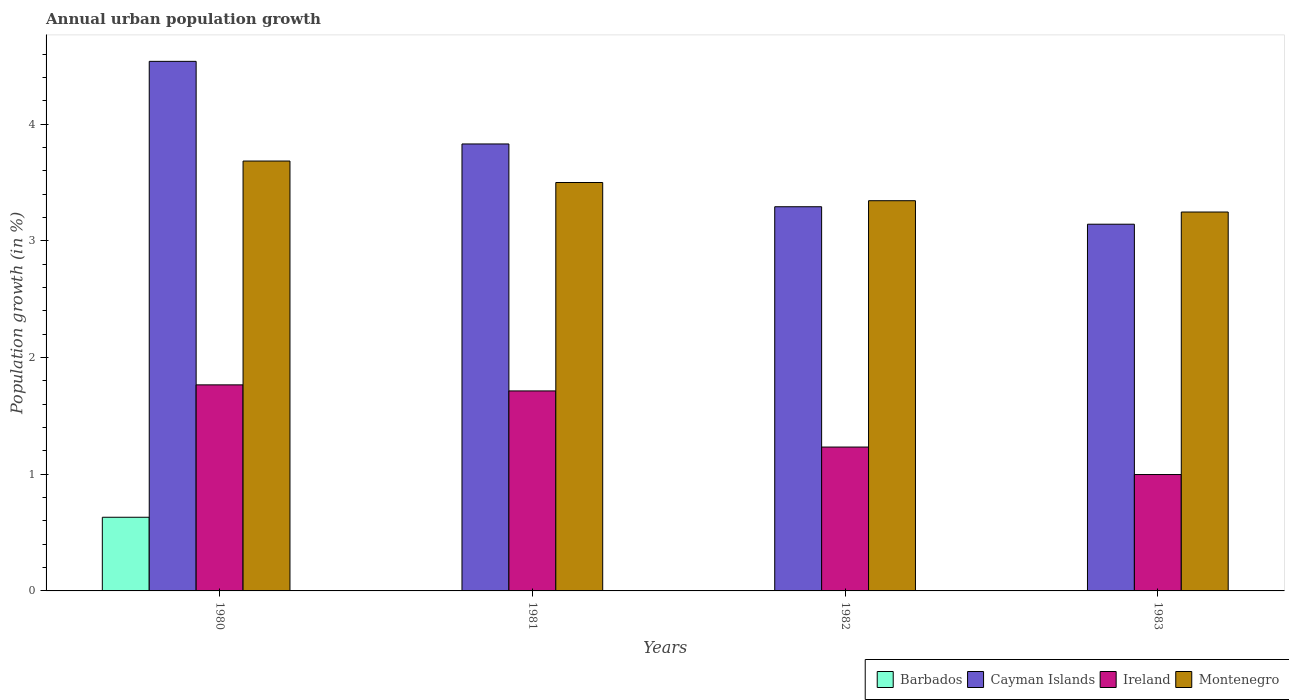How many different coloured bars are there?
Offer a very short reply. 4. Are the number of bars per tick equal to the number of legend labels?
Keep it short and to the point. No. Are the number of bars on each tick of the X-axis equal?
Give a very brief answer. No. How many bars are there on the 2nd tick from the right?
Offer a very short reply. 3. What is the label of the 4th group of bars from the left?
Your response must be concise. 1983. What is the percentage of urban population growth in Barbados in 1982?
Offer a very short reply. 0. Across all years, what is the maximum percentage of urban population growth in Cayman Islands?
Ensure brevity in your answer.  4.54. Across all years, what is the minimum percentage of urban population growth in Barbados?
Offer a terse response. 0. In which year was the percentage of urban population growth in Ireland maximum?
Offer a very short reply. 1980. What is the total percentage of urban population growth in Ireland in the graph?
Your answer should be compact. 5.71. What is the difference between the percentage of urban population growth in Ireland in 1982 and that in 1983?
Keep it short and to the point. 0.24. What is the difference between the percentage of urban population growth in Ireland in 1981 and the percentage of urban population growth in Cayman Islands in 1983?
Keep it short and to the point. -1.43. What is the average percentage of urban population growth in Ireland per year?
Make the answer very short. 1.43. In the year 1982, what is the difference between the percentage of urban population growth in Montenegro and percentage of urban population growth in Ireland?
Your answer should be compact. 2.11. What is the ratio of the percentage of urban population growth in Ireland in 1981 to that in 1982?
Give a very brief answer. 1.39. Is the percentage of urban population growth in Cayman Islands in 1981 less than that in 1983?
Your answer should be compact. No. Is the difference between the percentage of urban population growth in Montenegro in 1980 and 1982 greater than the difference between the percentage of urban population growth in Ireland in 1980 and 1982?
Provide a succinct answer. No. What is the difference between the highest and the second highest percentage of urban population growth in Montenegro?
Make the answer very short. 0.18. What is the difference between the highest and the lowest percentage of urban population growth in Ireland?
Keep it short and to the point. 0.77. In how many years, is the percentage of urban population growth in Ireland greater than the average percentage of urban population growth in Ireland taken over all years?
Offer a terse response. 2. Is the sum of the percentage of urban population growth in Cayman Islands in 1981 and 1983 greater than the maximum percentage of urban population growth in Montenegro across all years?
Give a very brief answer. Yes. Is it the case that in every year, the sum of the percentage of urban population growth in Montenegro and percentage of urban population growth in Cayman Islands is greater than the sum of percentage of urban population growth in Barbados and percentage of urban population growth in Ireland?
Provide a short and direct response. Yes. Are all the bars in the graph horizontal?
Your answer should be very brief. No. What is the difference between two consecutive major ticks on the Y-axis?
Your answer should be very brief. 1. Where does the legend appear in the graph?
Make the answer very short. Bottom right. How are the legend labels stacked?
Your answer should be compact. Horizontal. What is the title of the graph?
Provide a succinct answer. Annual urban population growth. Does "Guinea" appear as one of the legend labels in the graph?
Keep it short and to the point. No. What is the label or title of the Y-axis?
Provide a short and direct response. Population growth (in %). What is the Population growth (in %) of Barbados in 1980?
Offer a terse response. 0.63. What is the Population growth (in %) of Cayman Islands in 1980?
Make the answer very short. 4.54. What is the Population growth (in %) of Ireland in 1980?
Provide a succinct answer. 1.77. What is the Population growth (in %) in Montenegro in 1980?
Your answer should be compact. 3.68. What is the Population growth (in %) in Cayman Islands in 1981?
Ensure brevity in your answer.  3.83. What is the Population growth (in %) in Ireland in 1981?
Provide a succinct answer. 1.71. What is the Population growth (in %) of Montenegro in 1981?
Provide a short and direct response. 3.5. What is the Population growth (in %) of Barbados in 1982?
Your response must be concise. 0. What is the Population growth (in %) of Cayman Islands in 1982?
Your answer should be very brief. 3.29. What is the Population growth (in %) of Ireland in 1982?
Give a very brief answer. 1.23. What is the Population growth (in %) in Montenegro in 1982?
Your answer should be compact. 3.34. What is the Population growth (in %) of Barbados in 1983?
Make the answer very short. 0. What is the Population growth (in %) of Cayman Islands in 1983?
Offer a very short reply. 3.14. What is the Population growth (in %) of Ireland in 1983?
Make the answer very short. 1. What is the Population growth (in %) in Montenegro in 1983?
Offer a terse response. 3.25. Across all years, what is the maximum Population growth (in %) in Barbados?
Make the answer very short. 0.63. Across all years, what is the maximum Population growth (in %) of Cayman Islands?
Make the answer very short. 4.54. Across all years, what is the maximum Population growth (in %) in Ireland?
Offer a very short reply. 1.77. Across all years, what is the maximum Population growth (in %) in Montenegro?
Your response must be concise. 3.68. Across all years, what is the minimum Population growth (in %) of Barbados?
Make the answer very short. 0. Across all years, what is the minimum Population growth (in %) of Cayman Islands?
Make the answer very short. 3.14. Across all years, what is the minimum Population growth (in %) of Ireland?
Your answer should be compact. 1. Across all years, what is the minimum Population growth (in %) in Montenegro?
Provide a succinct answer. 3.25. What is the total Population growth (in %) of Barbados in the graph?
Your answer should be very brief. 0.63. What is the total Population growth (in %) of Cayman Islands in the graph?
Offer a very short reply. 14.8. What is the total Population growth (in %) in Ireland in the graph?
Provide a succinct answer. 5.71. What is the total Population growth (in %) in Montenegro in the graph?
Provide a short and direct response. 13.77. What is the difference between the Population growth (in %) of Cayman Islands in 1980 and that in 1981?
Provide a succinct answer. 0.71. What is the difference between the Population growth (in %) of Ireland in 1980 and that in 1981?
Provide a short and direct response. 0.05. What is the difference between the Population growth (in %) of Montenegro in 1980 and that in 1981?
Provide a short and direct response. 0.18. What is the difference between the Population growth (in %) of Cayman Islands in 1980 and that in 1982?
Your response must be concise. 1.25. What is the difference between the Population growth (in %) of Ireland in 1980 and that in 1982?
Your answer should be compact. 0.53. What is the difference between the Population growth (in %) in Montenegro in 1980 and that in 1982?
Provide a short and direct response. 0.34. What is the difference between the Population growth (in %) of Cayman Islands in 1980 and that in 1983?
Make the answer very short. 1.4. What is the difference between the Population growth (in %) in Ireland in 1980 and that in 1983?
Offer a terse response. 0.77. What is the difference between the Population growth (in %) in Montenegro in 1980 and that in 1983?
Your answer should be very brief. 0.44. What is the difference between the Population growth (in %) in Cayman Islands in 1981 and that in 1982?
Provide a succinct answer. 0.54. What is the difference between the Population growth (in %) of Ireland in 1981 and that in 1982?
Make the answer very short. 0.48. What is the difference between the Population growth (in %) of Montenegro in 1981 and that in 1982?
Ensure brevity in your answer.  0.16. What is the difference between the Population growth (in %) of Cayman Islands in 1981 and that in 1983?
Keep it short and to the point. 0.69. What is the difference between the Population growth (in %) in Ireland in 1981 and that in 1983?
Make the answer very short. 0.72. What is the difference between the Population growth (in %) of Montenegro in 1981 and that in 1983?
Provide a short and direct response. 0.25. What is the difference between the Population growth (in %) of Cayman Islands in 1982 and that in 1983?
Offer a very short reply. 0.15. What is the difference between the Population growth (in %) of Ireland in 1982 and that in 1983?
Provide a short and direct response. 0.24. What is the difference between the Population growth (in %) in Montenegro in 1982 and that in 1983?
Your response must be concise. 0.1. What is the difference between the Population growth (in %) of Barbados in 1980 and the Population growth (in %) of Cayman Islands in 1981?
Your answer should be very brief. -3.2. What is the difference between the Population growth (in %) of Barbados in 1980 and the Population growth (in %) of Ireland in 1981?
Give a very brief answer. -1.08. What is the difference between the Population growth (in %) of Barbados in 1980 and the Population growth (in %) of Montenegro in 1981?
Your answer should be very brief. -2.87. What is the difference between the Population growth (in %) of Cayman Islands in 1980 and the Population growth (in %) of Ireland in 1981?
Your response must be concise. 2.82. What is the difference between the Population growth (in %) of Cayman Islands in 1980 and the Population growth (in %) of Montenegro in 1981?
Provide a succinct answer. 1.04. What is the difference between the Population growth (in %) in Ireland in 1980 and the Population growth (in %) in Montenegro in 1981?
Your answer should be very brief. -1.73. What is the difference between the Population growth (in %) in Barbados in 1980 and the Population growth (in %) in Cayman Islands in 1982?
Make the answer very short. -2.66. What is the difference between the Population growth (in %) of Barbados in 1980 and the Population growth (in %) of Ireland in 1982?
Offer a very short reply. -0.6. What is the difference between the Population growth (in %) of Barbados in 1980 and the Population growth (in %) of Montenegro in 1982?
Your answer should be very brief. -2.71. What is the difference between the Population growth (in %) of Cayman Islands in 1980 and the Population growth (in %) of Ireland in 1982?
Provide a succinct answer. 3.3. What is the difference between the Population growth (in %) in Cayman Islands in 1980 and the Population growth (in %) in Montenegro in 1982?
Offer a terse response. 1.19. What is the difference between the Population growth (in %) of Ireland in 1980 and the Population growth (in %) of Montenegro in 1982?
Your response must be concise. -1.58. What is the difference between the Population growth (in %) in Barbados in 1980 and the Population growth (in %) in Cayman Islands in 1983?
Offer a terse response. -2.51. What is the difference between the Population growth (in %) of Barbados in 1980 and the Population growth (in %) of Ireland in 1983?
Offer a terse response. -0.37. What is the difference between the Population growth (in %) of Barbados in 1980 and the Population growth (in %) of Montenegro in 1983?
Provide a succinct answer. -2.62. What is the difference between the Population growth (in %) of Cayman Islands in 1980 and the Population growth (in %) of Ireland in 1983?
Keep it short and to the point. 3.54. What is the difference between the Population growth (in %) in Cayman Islands in 1980 and the Population growth (in %) in Montenegro in 1983?
Your answer should be compact. 1.29. What is the difference between the Population growth (in %) in Ireland in 1980 and the Population growth (in %) in Montenegro in 1983?
Your answer should be very brief. -1.48. What is the difference between the Population growth (in %) of Cayman Islands in 1981 and the Population growth (in %) of Ireland in 1982?
Your response must be concise. 2.6. What is the difference between the Population growth (in %) of Cayman Islands in 1981 and the Population growth (in %) of Montenegro in 1982?
Give a very brief answer. 0.49. What is the difference between the Population growth (in %) of Ireland in 1981 and the Population growth (in %) of Montenegro in 1982?
Offer a very short reply. -1.63. What is the difference between the Population growth (in %) of Cayman Islands in 1981 and the Population growth (in %) of Ireland in 1983?
Provide a short and direct response. 2.83. What is the difference between the Population growth (in %) in Cayman Islands in 1981 and the Population growth (in %) in Montenegro in 1983?
Your answer should be very brief. 0.58. What is the difference between the Population growth (in %) of Ireland in 1981 and the Population growth (in %) of Montenegro in 1983?
Give a very brief answer. -1.53. What is the difference between the Population growth (in %) of Cayman Islands in 1982 and the Population growth (in %) of Ireland in 1983?
Offer a very short reply. 2.29. What is the difference between the Population growth (in %) of Cayman Islands in 1982 and the Population growth (in %) of Montenegro in 1983?
Offer a terse response. 0.05. What is the difference between the Population growth (in %) of Ireland in 1982 and the Population growth (in %) of Montenegro in 1983?
Ensure brevity in your answer.  -2.01. What is the average Population growth (in %) in Barbados per year?
Ensure brevity in your answer.  0.16. What is the average Population growth (in %) in Ireland per year?
Your response must be concise. 1.43. What is the average Population growth (in %) in Montenegro per year?
Offer a very short reply. 3.44. In the year 1980, what is the difference between the Population growth (in %) in Barbados and Population growth (in %) in Cayman Islands?
Keep it short and to the point. -3.91. In the year 1980, what is the difference between the Population growth (in %) of Barbados and Population growth (in %) of Ireland?
Provide a succinct answer. -1.13. In the year 1980, what is the difference between the Population growth (in %) of Barbados and Population growth (in %) of Montenegro?
Make the answer very short. -3.05. In the year 1980, what is the difference between the Population growth (in %) of Cayman Islands and Population growth (in %) of Ireland?
Offer a very short reply. 2.77. In the year 1980, what is the difference between the Population growth (in %) of Cayman Islands and Population growth (in %) of Montenegro?
Keep it short and to the point. 0.85. In the year 1980, what is the difference between the Population growth (in %) in Ireland and Population growth (in %) in Montenegro?
Your response must be concise. -1.92. In the year 1981, what is the difference between the Population growth (in %) in Cayman Islands and Population growth (in %) in Ireland?
Offer a terse response. 2.12. In the year 1981, what is the difference between the Population growth (in %) of Cayman Islands and Population growth (in %) of Montenegro?
Ensure brevity in your answer.  0.33. In the year 1981, what is the difference between the Population growth (in %) in Ireland and Population growth (in %) in Montenegro?
Give a very brief answer. -1.79. In the year 1982, what is the difference between the Population growth (in %) of Cayman Islands and Population growth (in %) of Ireland?
Keep it short and to the point. 2.06. In the year 1982, what is the difference between the Population growth (in %) in Cayman Islands and Population growth (in %) in Montenegro?
Your answer should be very brief. -0.05. In the year 1982, what is the difference between the Population growth (in %) in Ireland and Population growth (in %) in Montenegro?
Give a very brief answer. -2.11. In the year 1983, what is the difference between the Population growth (in %) in Cayman Islands and Population growth (in %) in Ireland?
Provide a succinct answer. 2.14. In the year 1983, what is the difference between the Population growth (in %) in Cayman Islands and Population growth (in %) in Montenegro?
Offer a terse response. -0.1. In the year 1983, what is the difference between the Population growth (in %) in Ireland and Population growth (in %) in Montenegro?
Your answer should be compact. -2.25. What is the ratio of the Population growth (in %) of Cayman Islands in 1980 to that in 1981?
Ensure brevity in your answer.  1.18. What is the ratio of the Population growth (in %) of Ireland in 1980 to that in 1981?
Offer a terse response. 1.03. What is the ratio of the Population growth (in %) of Montenegro in 1980 to that in 1981?
Your answer should be compact. 1.05. What is the ratio of the Population growth (in %) of Cayman Islands in 1980 to that in 1982?
Keep it short and to the point. 1.38. What is the ratio of the Population growth (in %) of Ireland in 1980 to that in 1982?
Offer a terse response. 1.43. What is the ratio of the Population growth (in %) of Montenegro in 1980 to that in 1982?
Your answer should be compact. 1.1. What is the ratio of the Population growth (in %) in Cayman Islands in 1980 to that in 1983?
Ensure brevity in your answer.  1.44. What is the ratio of the Population growth (in %) of Ireland in 1980 to that in 1983?
Provide a succinct answer. 1.77. What is the ratio of the Population growth (in %) of Montenegro in 1980 to that in 1983?
Your answer should be compact. 1.13. What is the ratio of the Population growth (in %) in Cayman Islands in 1981 to that in 1982?
Provide a short and direct response. 1.16. What is the ratio of the Population growth (in %) of Ireland in 1981 to that in 1982?
Your answer should be very brief. 1.39. What is the ratio of the Population growth (in %) in Montenegro in 1981 to that in 1982?
Give a very brief answer. 1.05. What is the ratio of the Population growth (in %) in Cayman Islands in 1981 to that in 1983?
Provide a short and direct response. 1.22. What is the ratio of the Population growth (in %) in Ireland in 1981 to that in 1983?
Keep it short and to the point. 1.72. What is the ratio of the Population growth (in %) in Montenegro in 1981 to that in 1983?
Your response must be concise. 1.08. What is the ratio of the Population growth (in %) of Cayman Islands in 1982 to that in 1983?
Provide a succinct answer. 1.05. What is the ratio of the Population growth (in %) of Ireland in 1982 to that in 1983?
Your response must be concise. 1.24. What is the ratio of the Population growth (in %) in Montenegro in 1982 to that in 1983?
Your answer should be very brief. 1.03. What is the difference between the highest and the second highest Population growth (in %) in Cayman Islands?
Your answer should be very brief. 0.71. What is the difference between the highest and the second highest Population growth (in %) of Ireland?
Offer a terse response. 0.05. What is the difference between the highest and the second highest Population growth (in %) in Montenegro?
Give a very brief answer. 0.18. What is the difference between the highest and the lowest Population growth (in %) of Barbados?
Offer a terse response. 0.63. What is the difference between the highest and the lowest Population growth (in %) of Cayman Islands?
Make the answer very short. 1.4. What is the difference between the highest and the lowest Population growth (in %) in Ireland?
Provide a succinct answer. 0.77. What is the difference between the highest and the lowest Population growth (in %) in Montenegro?
Keep it short and to the point. 0.44. 